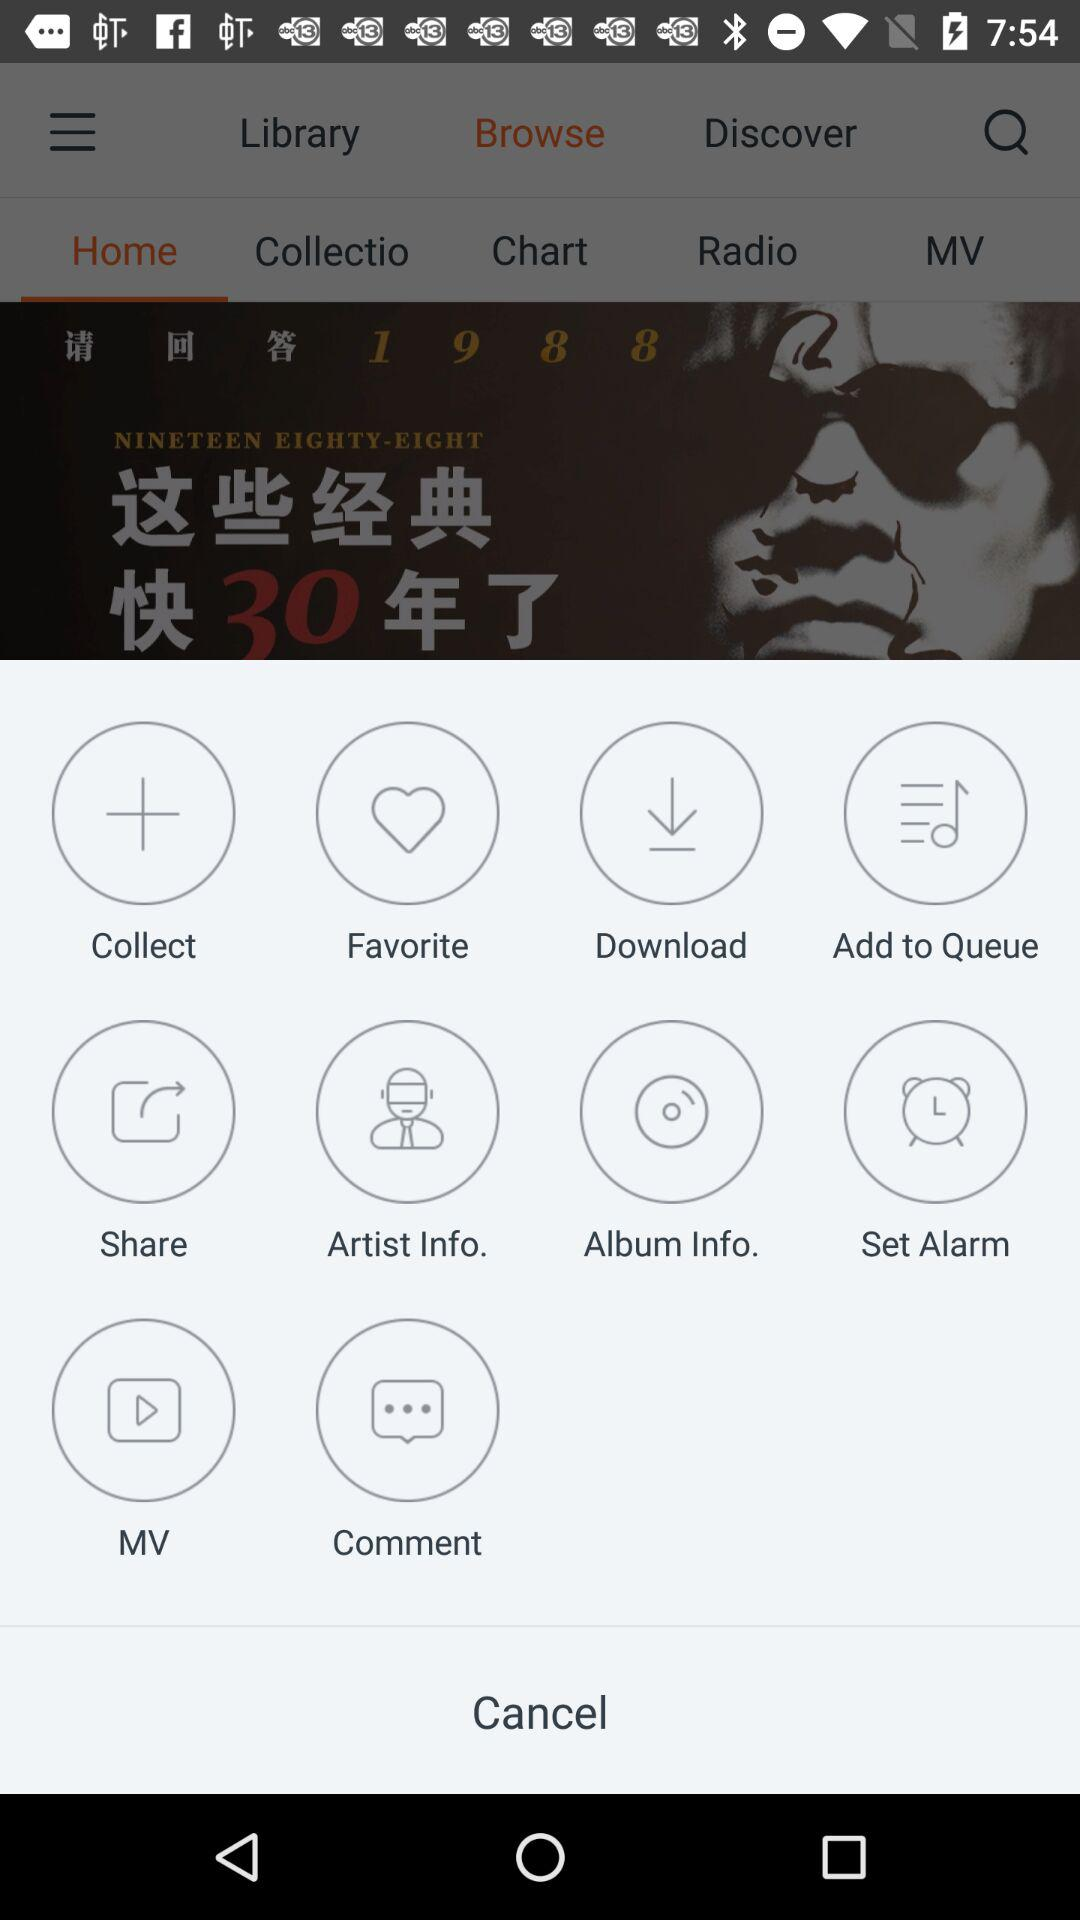What is the selected option? The selected option is "Home". 